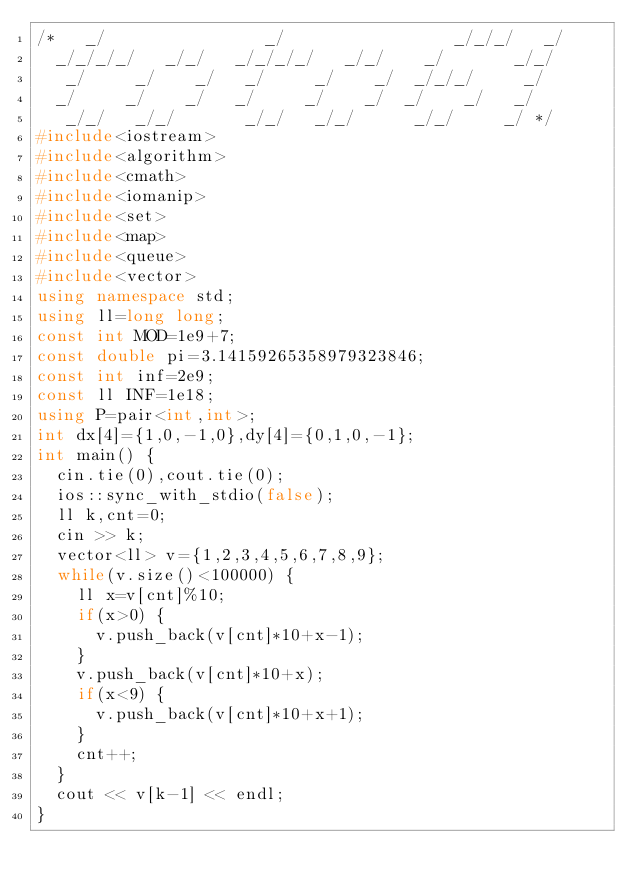Convert code to text. <code><loc_0><loc_0><loc_500><loc_500><_C++_>/*   _/                _/                 _/_/_/   _/
  _/_/_/_/   _/_/   _/_/_/_/   _/_/    _/       _/_/
   _/     _/    _/   _/     _/    _/  _/_/_/     _/
  _/     _/    _/   _/     _/    _/  _/    _/   _/
   _/_/   _/_/       _/_/   _/_/      _/_/     _/ */
#include<iostream>
#include<algorithm>
#include<cmath>
#include<iomanip>
#include<set>
#include<map>
#include<queue>
#include<vector>
using namespace std;
using ll=long long;
const int MOD=1e9+7;
const double pi=3.14159265358979323846;
const int inf=2e9;
const ll INF=1e18;
using P=pair<int,int>;
int dx[4]={1,0,-1,0},dy[4]={0,1,0,-1};
int main() {
  cin.tie(0),cout.tie(0);
  ios::sync_with_stdio(false);
  ll k,cnt=0;
  cin >> k;
  vector<ll> v={1,2,3,4,5,6,7,8,9};
  while(v.size()<100000) {
    ll x=v[cnt]%10;
    if(x>0) {
      v.push_back(v[cnt]*10+x-1);
    }
    v.push_back(v[cnt]*10+x);
    if(x<9) {
      v.push_back(v[cnt]*10+x+1);
    }
    cnt++;
  }
  cout << v[k-1] << endl;
}</code> 